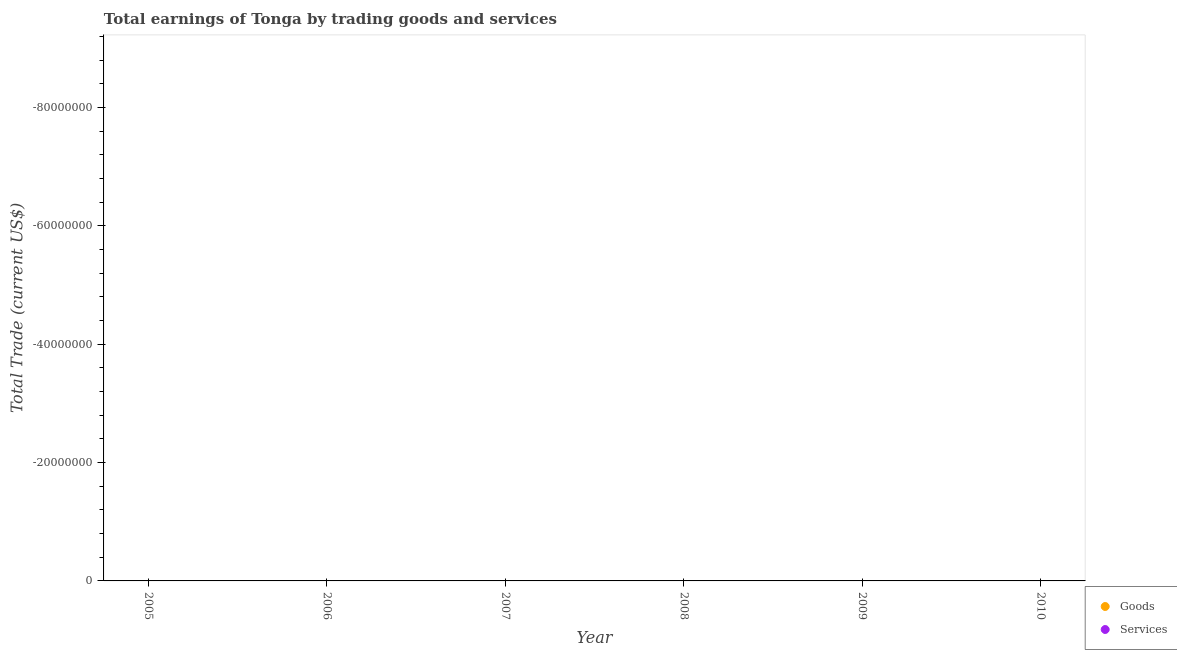How many different coloured dotlines are there?
Offer a very short reply. 0. What is the amount earned by trading services in 2008?
Provide a short and direct response. 0. What is the difference between the amount earned by trading services in 2007 and the amount earned by trading goods in 2009?
Make the answer very short. 0. In how many years, is the amount earned by trading services greater than the average amount earned by trading services taken over all years?
Ensure brevity in your answer.  0. How many years are there in the graph?
Make the answer very short. 6. What is the difference between two consecutive major ticks on the Y-axis?
Give a very brief answer. 2.00e+07. How many legend labels are there?
Make the answer very short. 2. How are the legend labels stacked?
Keep it short and to the point. Vertical. What is the title of the graph?
Offer a very short reply. Total earnings of Tonga by trading goods and services. Does "Infant" appear as one of the legend labels in the graph?
Ensure brevity in your answer.  No. What is the label or title of the Y-axis?
Your answer should be very brief. Total Trade (current US$). What is the Total Trade (current US$) of Goods in 2005?
Provide a succinct answer. 0. What is the Total Trade (current US$) of Services in 2006?
Your response must be concise. 0. What is the Total Trade (current US$) in Services in 2009?
Your response must be concise. 0. What is the Total Trade (current US$) of Goods in 2010?
Your answer should be very brief. 0. What is the Total Trade (current US$) of Services in 2010?
Ensure brevity in your answer.  0. What is the total Total Trade (current US$) in Services in the graph?
Give a very brief answer. 0. What is the average Total Trade (current US$) in Goods per year?
Your answer should be compact. 0. 